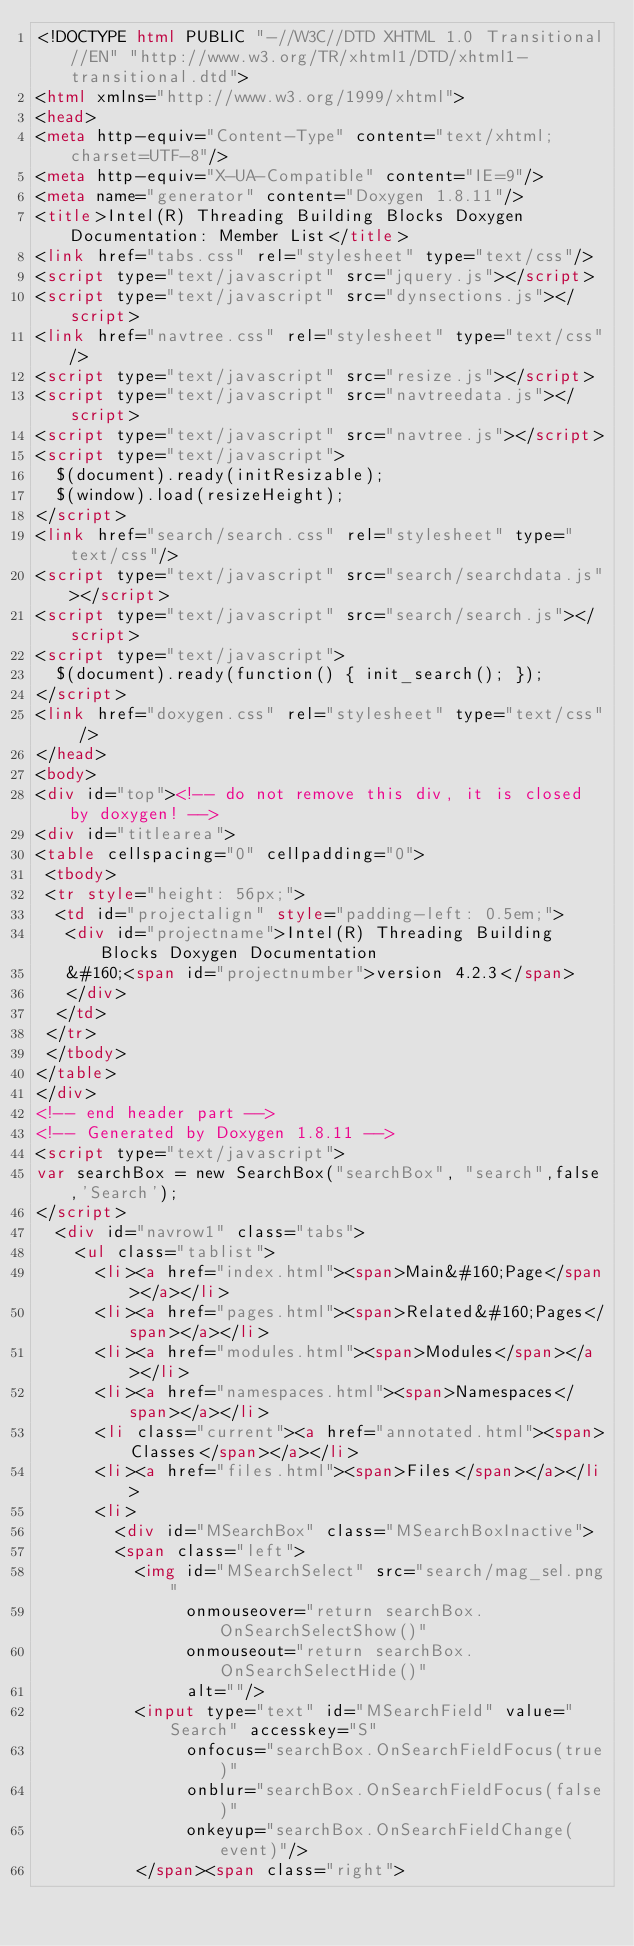Convert code to text. <code><loc_0><loc_0><loc_500><loc_500><_HTML_><!DOCTYPE html PUBLIC "-//W3C//DTD XHTML 1.0 Transitional//EN" "http://www.w3.org/TR/xhtml1/DTD/xhtml1-transitional.dtd">
<html xmlns="http://www.w3.org/1999/xhtml">
<head>
<meta http-equiv="Content-Type" content="text/xhtml;charset=UTF-8"/>
<meta http-equiv="X-UA-Compatible" content="IE=9"/>
<meta name="generator" content="Doxygen 1.8.11"/>
<title>Intel(R) Threading Building Blocks Doxygen Documentation: Member List</title>
<link href="tabs.css" rel="stylesheet" type="text/css"/>
<script type="text/javascript" src="jquery.js"></script>
<script type="text/javascript" src="dynsections.js"></script>
<link href="navtree.css" rel="stylesheet" type="text/css"/>
<script type="text/javascript" src="resize.js"></script>
<script type="text/javascript" src="navtreedata.js"></script>
<script type="text/javascript" src="navtree.js"></script>
<script type="text/javascript">
  $(document).ready(initResizable);
  $(window).load(resizeHeight);
</script>
<link href="search/search.css" rel="stylesheet" type="text/css"/>
<script type="text/javascript" src="search/searchdata.js"></script>
<script type="text/javascript" src="search/search.js"></script>
<script type="text/javascript">
  $(document).ready(function() { init_search(); });
</script>
<link href="doxygen.css" rel="stylesheet" type="text/css" />
</head>
<body>
<div id="top"><!-- do not remove this div, it is closed by doxygen! -->
<div id="titlearea">
<table cellspacing="0" cellpadding="0">
 <tbody>
 <tr style="height: 56px;">
  <td id="projectalign" style="padding-left: 0.5em;">
   <div id="projectname">Intel(R) Threading Building Blocks Doxygen Documentation
   &#160;<span id="projectnumber">version 4.2.3</span>
   </div>
  </td>
 </tr>
 </tbody>
</table>
</div>
<!-- end header part -->
<!-- Generated by Doxygen 1.8.11 -->
<script type="text/javascript">
var searchBox = new SearchBox("searchBox", "search",false,'Search');
</script>
  <div id="navrow1" class="tabs">
    <ul class="tablist">
      <li><a href="index.html"><span>Main&#160;Page</span></a></li>
      <li><a href="pages.html"><span>Related&#160;Pages</span></a></li>
      <li><a href="modules.html"><span>Modules</span></a></li>
      <li><a href="namespaces.html"><span>Namespaces</span></a></li>
      <li class="current"><a href="annotated.html"><span>Classes</span></a></li>
      <li><a href="files.html"><span>Files</span></a></li>
      <li>
        <div id="MSearchBox" class="MSearchBoxInactive">
        <span class="left">
          <img id="MSearchSelect" src="search/mag_sel.png"
               onmouseover="return searchBox.OnSearchSelectShow()"
               onmouseout="return searchBox.OnSearchSelectHide()"
               alt=""/>
          <input type="text" id="MSearchField" value="Search" accesskey="S"
               onfocus="searchBox.OnSearchFieldFocus(true)" 
               onblur="searchBox.OnSearchFieldFocus(false)" 
               onkeyup="searchBox.OnSearchFieldChange(event)"/>
          </span><span class="right"></code> 